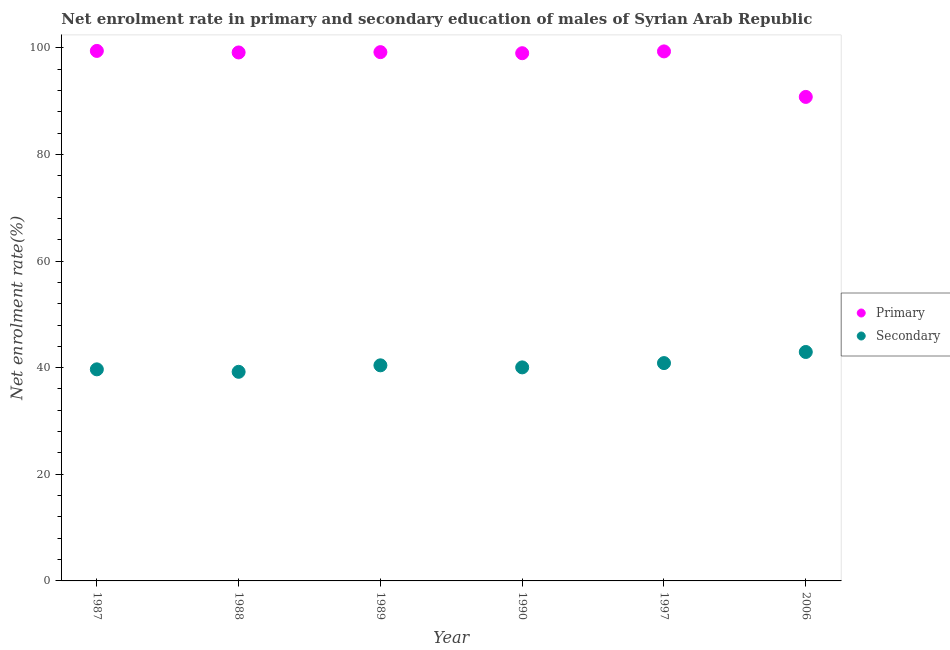How many different coloured dotlines are there?
Offer a very short reply. 2. What is the enrollment rate in primary education in 2006?
Ensure brevity in your answer.  90.78. Across all years, what is the maximum enrollment rate in secondary education?
Keep it short and to the point. 42.94. Across all years, what is the minimum enrollment rate in primary education?
Your answer should be very brief. 90.78. What is the total enrollment rate in secondary education in the graph?
Offer a terse response. 243.19. What is the difference between the enrollment rate in primary education in 1987 and that in 1988?
Keep it short and to the point. 0.29. What is the difference between the enrollment rate in secondary education in 1988 and the enrollment rate in primary education in 1990?
Your answer should be compact. -59.76. What is the average enrollment rate in secondary education per year?
Offer a terse response. 40.53. In the year 1988, what is the difference between the enrollment rate in secondary education and enrollment rate in primary education?
Make the answer very short. -59.9. What is the ratio of the enrollment rate in primary education in 1990 to that in 1997?
Keep it short and to the point. 1. Is the difference between the enrollment rate in secondary education in 1987 and 1988 greater than the difference between the enrollment rate in primary education in 1987 and 1988?
Offer a terse response. Yes. What is the difference between the highest and the second highest enrollment rate in primary education?
Offer a terse response. 0.09. What is the difference between the highest and the lowest enrollment rate in secondary education?
Provide a short and direct response. 3.72. Does the enrollment rate in secondary education monotonically increase over the years?
Keep it short and to the point. No. Is the enrollment rate in secondary education strictly greater than the enrollment rate in primary education over the years?
Make the answer very short. No. Is the enrollment rate in secondary education strictly less than the enrollment rate in primary education over the years?
Your response must be concise. Yes. How many dotlines are there?
Make the answer very short. 2. How many years are there in the graph?
Provide a succinct answer. 6. Are the values on the major ticks of Y-axis written in scientific E-notation?
Provide a short and direct response. No. Does the graph contain any zero values?
Offer a terse response. No. What is the title of the graph?
Provide a short and direct response. Net enrolment rate in primary and secondary education of males of Syrian Arab Republic. Does "Food and tobacco" appear as one of the legend labels in the graph?
Your response must be concise. No. What is the label or title of the Y-axis?
Provide a succinct answer. Net enrolment rate(%). What is the Net enrolment rate(%) in Primary in 1987?
Your response must be concise. 99.41. What is the Net enrolment rate(%) in Secondary in 1987?
Make the answer very short. 39.68. What is the Net enrolment rate(%) of Primary in 1988?
Your answer should be very brief. 99.12. What is the Net enrolment rate(%) of Secondary in 1988?
Provide a short and direct response. 39.22. What is the Net enrolment rate(%) of Primary in 1989?
Your answer should be compact. 99.18. What is the Net enrolment rate(%) of Secondary in 1989?
Your response must be concise. 40.44. What is the Net enrolment rate(%) of Primary in 1990?
Provide a short and direct response. 98.98. What is the Net enrolment rate(%) of Secondary in 1990?
Keep it short and to the point. 40.05. What is the Net enrolment rate(%) of Primary in 1997?
Offer a terse response. 99.32. What is the Net enrolment rate(%) of Secondary in 1997?
Give a very brief answer. 40.86. What is the Net enrolment rate(%) of Primary in 2006?
Keep it short and to the point. 90.78. What is the Net enrolment rate(%) in Secondary in 2006?
Your response must be concise. 42.94. Across all years, what is the maximum Net enrolment rate(%) in Primary?
Ensure brevity in your answer.  99.41. Across all years, what is the maximum Net enrolment rate(%) of Secondary?
Your response must be concise. 42.94. Across all years, what is the minimum Net enrolment rate(%) in Primary?
Provide a short and direct response. 90.78. Across all years, what is the minimum Net enrolment rate(%) of Secondary?
Make the answer very short. 39.22. What is the total Net enrolment rate(%) of Primary in the graph?
Offer a very short reply. 586.77. What is the total Net enrolment rate(%) in Secondary in the graph?
Your answer should be compact. 243.19. What is the difference between the Net enrolment rate(%) in Primary in 1987 and that in 1988?
Offer a very short reply. 0.29. What is the difference between the Net enrolment rate(%) in Secondary in 1987 and that in 1988?
Your answer should be very brief. 0.46. What is the difference between the Net enrolment rate(%) in Primary in 1987 and that in 1989?
Keep it short and to the point. 0.23. What is the difference between the Net enrolment rate(%) of Secondary in 1987 and that in 1989?
Your answer should be very brief. -0.75. What is the difference between the Net enrolment rate(%) of Primary in 1987 and that in 1990?
Make the answer very short. 0.43. What is the difference between the Net enrolment rate(%) of Secondary in 1987 and that in 1990?
Offer a very short reply. -0.37. What is the difference between the Net enrolment rate(%) of Primary in 1987 and that in 1997?
Keep it short and to the point. 0.09. What is the difference between the Net enrolment rate(%) of Secondary in 1987 and that in 1997?
Make the answer very short. -1.17. What is the difference between the Net enrolment rate(%) of Primary in 1987 and that in 2006?
Provide a succinct answer. 8.63. What is the difference between the Net enrolment rate(%) of Secondary in 1987 and that in 2006?
Your answer should be very brief. -3.26. What is the difference between the Net enrolment rate(%) in Primary in 1988 and that in 1989?
Your response must be concise. -0.06. What is the difference between the Net enrolment rate(%) of Secondary in 1988 and that in 1989?
Give a very brief answer. -1.22. What is the difference between the Net enrolment rate(%) of Primary in 1988 and that in 1990?
Provide a succinct answer. 0.14. What is the difference between the Net enrolment rate(%) in Secondary in 1988 and that in 1990?
Keep it short and to the point. -0.83. What is the difference between the Net enrolment rate(%) of Primary in 1988 and that in 1997?
Your response must be concise. -0.2. What is the difference between the Net enrolment rate(%) in Secondary in 1988 and that in 1997?
Your response must be concise. -1.63. What is the difference between the Net enrolment rate(%) in Primary in 1988 and that in 2006?
Your response must be concise. 8.34. What is the difference between the Net enrolment rate(%) of Secondary in 1988 and that in 2006?
Give a very brief answer. -3.72. What is the difference between the Net enrolment rate(%) in Primary in 1989 and that in 1990?
Keep it short and to the point. 0.2. What is the difference between the Net enrolment rate(%) in Secondary in 1989 and that in 1990?
Your response must be concise. 0.39. What is the difference between the Net enrolment rate(%) in Primary in 1989 and that in 1997?
Ensure brevity in your answer.  -0.14. What is the difference between the Net enrolment rate(%) of Secondary in 1989 and that in 1997?
Your answer should be compact. -0.42. What is the difference between the Net enrolment rate(%) of Primary in 1989 and that in 2006?
Your response must be concise. 8.4. What is the difference between the Net enrolment rate(%) of Secondary in 1989 and that in 2006?
Give a very brief answer. -2.5. What is the difference between the Net enrolment rate(%) of Primary in 1990 and that in 1997?
Give a very brief answer. -0.34. What is the difference between the Net enrolment rate(%) of Secondary in 1990 and that in 1997?
Offer a very short reply. -0.8. What is the difference between the Net enrolment rate(%) in Primary in 1990 and that in 2006?
Provide a short and direct response. 8.2. What is the difference between the Net enrolment rate(%) of Secondary in 1990 and that in 2006?
Provide a short and direct response. -2.89. What is the difference between the Net enrolment rate(%) in Primary in 1997 and that in 2006?
Keep it short and to the point. 8.54. What is the difference between the Net enrolment rate(%) in Secondary in 1997 and that in 2006?
Your response must be concise. -2.08. What is the difference between the Net enrolment rate(%) in Primary in 1987 and the Net enrolment rate(%) in Secondary in 1988?
Offer a terse response. 60.19. What is the difference between the Net enrolment rate(%) in Primary in 1987 and the Net enrolment rate(%) in Secondary in 1989?
Your response must be concise. 58.97. What is the difference between the Net enrolment rate(%) in Primary in 1987 and the Net enrolment rate(%) in Secondary in 1990?
Ensure brevity in your answer.  59.36. What is the difference between the Net enrolment rate(%) of Primary in 1987 and the Net enrolment rate(%) of Secondary in 1997?
Keep it short and to the point. 58.55. What is the difference between the Net enrolment rate(%) in Primary in 1987 and the Net enrolment rate(%) in Secondary in 2006?
Your answer should be compact. 56.47. What is the difference between the Net enrolment rate(%) in Primary in 1988 and the Net enrolment rate(%) in Secondary in 1989?
Your answer should be compact. 58.68. What is the difference between the Net enrolment rate(%) in Primary in 1988 and the Net enrolment rate(%) in Secondary in 1990?
Your response must be concise. 59.07. What is the difference between the Net enrolment rate(%) of Primary in 1988 and the Net enrolment rate(%) of Secondary in 1997?
Provide a succinct answer. 58.26. What is the difference between the Net enrolment rate(%) in Primary in 1988 and the Net enrolment rate(%) in Secondary in 2006?
Your answer should be very brief. 56.18. What is the difference between the Net enrolment rate(%) in Primary in 1989 and the Net enrolment rate(%) in Secondary in 1990?
Your response must be concise. 59.13. What is the difference between the Net enrolment rate(%) of Primary in 1989 and the Net enrolment rate(%) of Secondary in 1997?
Offer a terse response. 58.32. What is the difference between the Net enrolment rate(%) in Primary in 1989 and the Net enrolment rate(%) in Secondary in 2006?
Provide a short and direct response. 56.24. What is the difference between the Net enrolment rate(%) in Primary in 1990 and the Net enrolment rate(%) in Secondary in 1997?
Your response must be concise. 58.12. What is the difference between the Net enrolment rate(%) in Primary in 1990 and the Net enrolment rate(%) in Secondary in 2006?
Your answer should be very brief. 56.04. What is the difference between the Net enrolment rate(%) in Primary in 1997 and the Net enrolment rate(%) in Secondary in 2006?
Your answer should be compact. 56.38. What is the average Net enrolment rate(%) of Primary per year?
Ensure brevity in your answer.  97.8. What is the average Net enrolment rate(%) of Secondary per year?
Keep it short and to the point. 40.53. In the year 1987, what is the difference between the Net enrolment rate(%) in Primary and Net enrolment rate(%) in Secondary?
Make the answer very short. 59.72. In the year 1988, what is the difference between the Net enrolment rate(%) in Primary and Net enrolment rate(%) in Secondary?
Keep it short and to the point. 59.9. In the year 1989, what is the difference between the Net enrolment rate(%) in Primary and Net enrolment rate(%) in Secondary?
Keep it short and to the point. 58.74. In the year 1990, what is the difference between the Net enrolment rate(%) in Primary and Net enrolment rate(%) in Secondary?
Keep it short and to the point. 58.93. In the year 1997, what is the difference between the Net enrolment rate(%) of Primary and Net enrolment rate(%) of Secondary?
Ensure brevity in your answer.  58.46. In the year 2006, what is the difference between the Net enrolment rate(%) of Primary and Net enrolment rate(%) of Secondary?
Provide a succinct answer. 47.84. What is the ratio of the Net enrolment rate(%) in Primary in 1987 to that in 1988?
Give a very brief answer. 1. What is the ratio of the Net enrolment rate(%) of Secondary in 1987 to that in 1988?
Make the answer very short. 1.01. What is the ratio of the Net enrolment rate(%) of Secondary in 1987 to that in 1989?
Your answer should be very brief. 0.98. What is the ratio of the Net enrolment rate(%) of Primary in 1987 to that in 1990?
Ensure brevity in your answer.  1. What is the ratio of the Net enrolment rate(%) of Secondary in 1987 to that in 1997?
Offer a very short reply. 0.97. What is the ratio of the Net enrolment rate(%) of Primary in 1987 to that in 2006?
Provide a succinct answer. 1.09. What is the ratio of the Net enrolment rate(%) of Secondary in 1987 to that in 2006?
Keep it short and to the point. 0.92. What is the ratio of the Net enrolment rate(%) in Secondary in 1988 to that in 1989?
Ensure brevity in your answer.  0.97. What is the ratio of the Net enrolment rate(%) of Primary in 1988 to that in 1990?
Your answer should be compact. 1. What is the ratio of the Net enrolment rate(%) in Secondary in 1988 to that in 1990?
Your answer should be compact. 0.98. What is the ratio of the Net enrolment rate(%) in Primary in 1988 to that in 1997?
Provide a short and direct response. 1. What is the ratio of the Net enrolment rate(%) of Primary in 1988 to that in 2006?
Provide a succinct answer. 1.09. What is the ratio of the Net enrolment rate(%) of Secondary in 1988 to that in 2006?
Your answer should be very brief. 0.91. What is the ratio of the Net enrolment rate(%) in Primary in 1989 to that in 1990?
Offer a terse response. 1. What is the ratio of the Net enrolment rate(%) of Secondary in 1989 to that in 1990?
Offer a terse response. 1.01. What is the ratio of the Net enrolment rate(%) in Primary in 1989 to that in 1997?
Provide a short and direct response. 1. What is the ratio of the Net enrolment rate(%) in Secondary in 1989 to that in 1997?
Give a very brief answer. 0.99. What is the ratio of the Net enrolment rate(%) in Primary in 1989 to that in 2006?
Offer a very short reply. 1.09. What is the ratio of the Net enrolment rate(%) of Secondary in 1989 to that in 2006?
Your response must be concise. 0.94. What is the ratio of the Net enrolment rate(%) of Secondary in 1990 to that in 1997?
Give a very brief answer. 0.98. What is the ratio of the Net enrolment rate(%) of Primary in 1990 to that in 2006?
Keep it short and to the point. 1.09. What is the ratio of the Net enrolment rate(%) in Secondary in 1990 to that in 2006?
Give a very brief answer. 0.93. What is the ratio of the Net enrolment rate(%) of Primary in 1997 to that in 2006?
Your answer should be compact. 1.09. What is the ratio of the Net enrolment rate(%) of Secondary in 1997 to that in 2006?
Give a very brief answer. 0.95. What is the difference between the highest and the second highest Net enrolment rate(%) in Primary?
Make the answer very short. 0.09. What is the difference between the highest and the second highest Net enrolment rate(%) in Secondary?
Keep it short and to the point. 2.08. What is the difference between the highest and the lowest Net enrolment rate(%) of Primary?
Provide a short and direct response. 8.63. What is the difference between the highest and the lowest Net enrolment rate(%) of Secondary?
Offer a terse response. 3.72. 